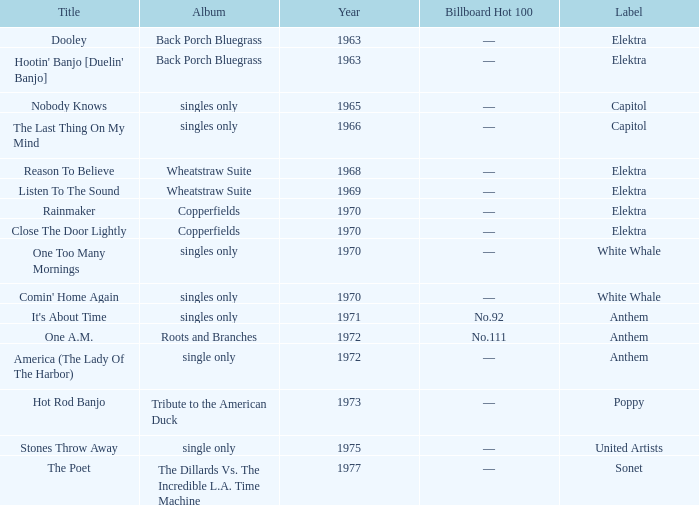What is the total years for roots and branches? 1972.0. Could you help me parse every detail presented in this table? {'header': ['Title', 'Album', 'Year', 'Billboard Hot 100', 'Label'], 'rows': [['Dooley', 'Back Porch Bluegrass', '1963', '—', 'Elektra'], ["Hootin' Banjo [Duelin' Banjo]", 'Back Porch Bluegrass', '1963', '—', 'Elektra'], ['Nobody Knows', 'singles only', '1965', '—', 'Capitol'], ['The Last Thing On My Mind', 'singles only', '1966', '—', 'Capitol'], ['Reason To Believe', 'Wheatstraw Suite', '1968', '—', 'Elektra'], ['Listen To The Sound', 'Wheatstraw Suite', '1969', '—', 'Elektra'], ['Rainmaker', 'Copperfields', '1970', '—', 'Elektra'], ['Close The Door Lightly', 'Copperfields', '1970', '—', 'Elektra'], ['One Too Many Mornings', 'singles only', '1970', '—', 'White Whale'], ["Comin' Home Again", 'singles only', '1970', '—', 'White Whale'], ["It's About Time", 'singles only', '1971', 'No.92', 'Anthem'], ['One A.M.', 'Roots and Branches', '1972', 'No.111', 'Anthem'], ['America (The Lady Of The Harbor)', 'single only', '1972', '—', 'Anthem'], ['Hot Rod Banjo', 'Tribute to the American Duck', '1973', '—', 'Poppy'], ['Stones Throw Away', 'single only', '1975', '—', 'United Artists'], ['The Poet', 'The Dillards Vs. The Incredible L.A. Time Machine', '1977', '—', 'Sonet']]} 